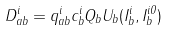<formula> <loc_0><loc_0><loc_500><loc_500>D _ { a b } ^ { i } = q _ { a b } ^ { i } c _ { b } ^ { i } Q _ { b } U _ { b } ( I _ { b } ^ { i } , I _ { b } ^ { i 0 } )</formula> 